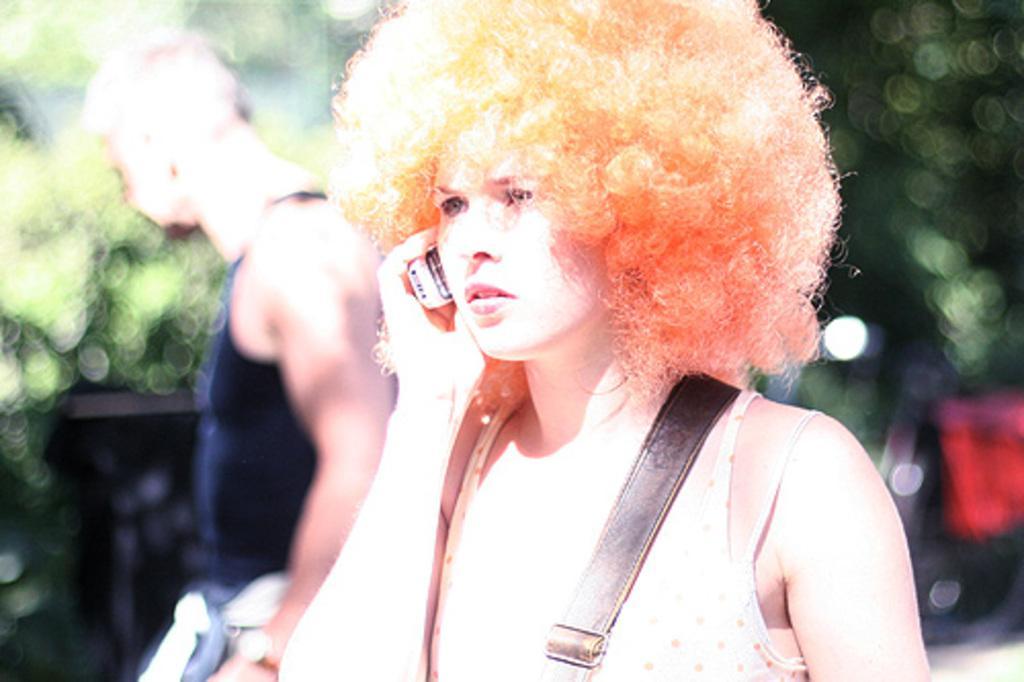Please provide a concise description of this image. In this image, we can persons wearing clothes. In the background, image is blurred. 